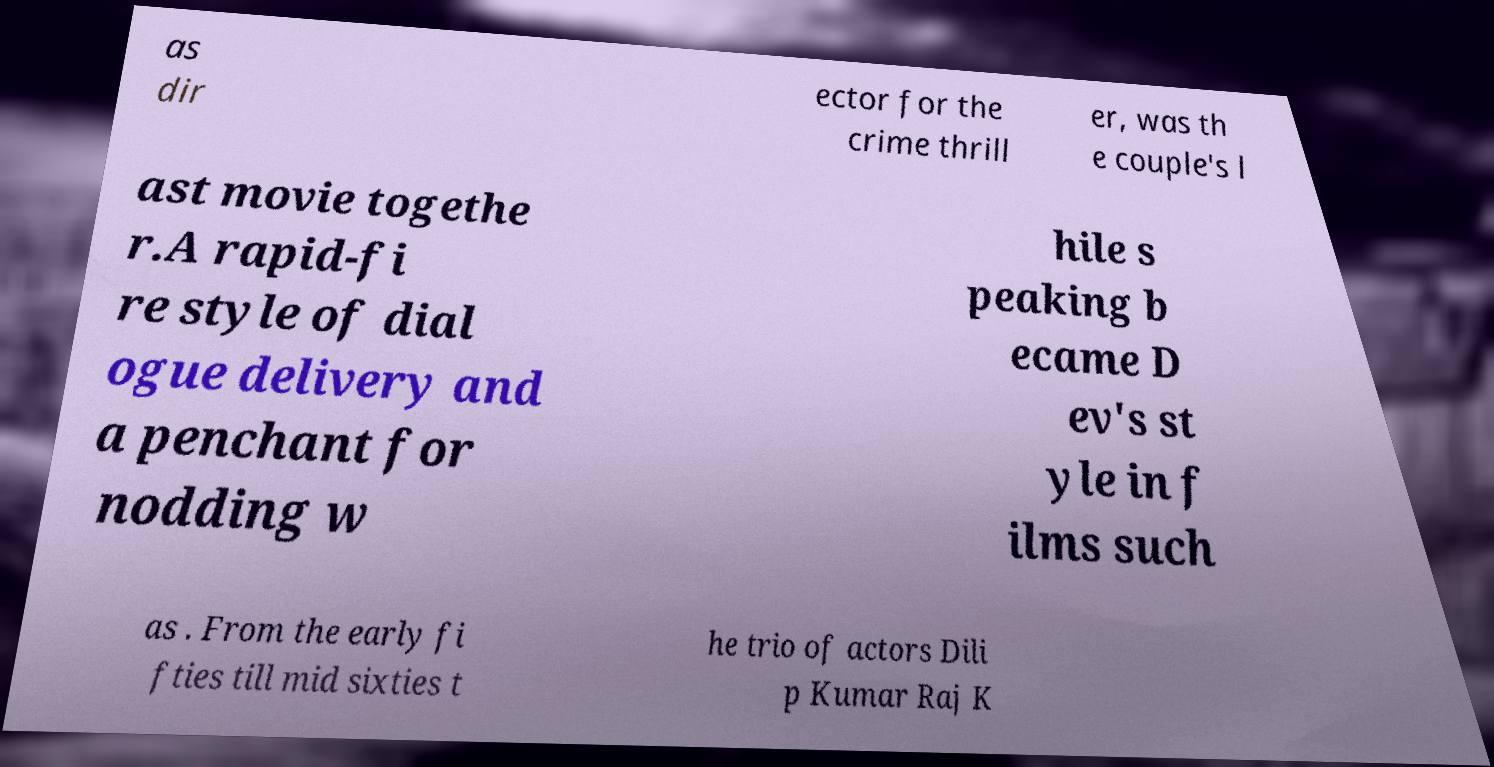I need the written content from this picture converted into text. Can you do that? as dir ector for the crime thrill er, was th e couple's l ast movie togethe r.A rapid-fi re style of dial ogue delivery and a penchant for nodding w hile s peaking b ecame D ev's st yle in f ilms such as . From the early fi fties till mid sixties t he trio of actors Dili p Kumar Raj K 